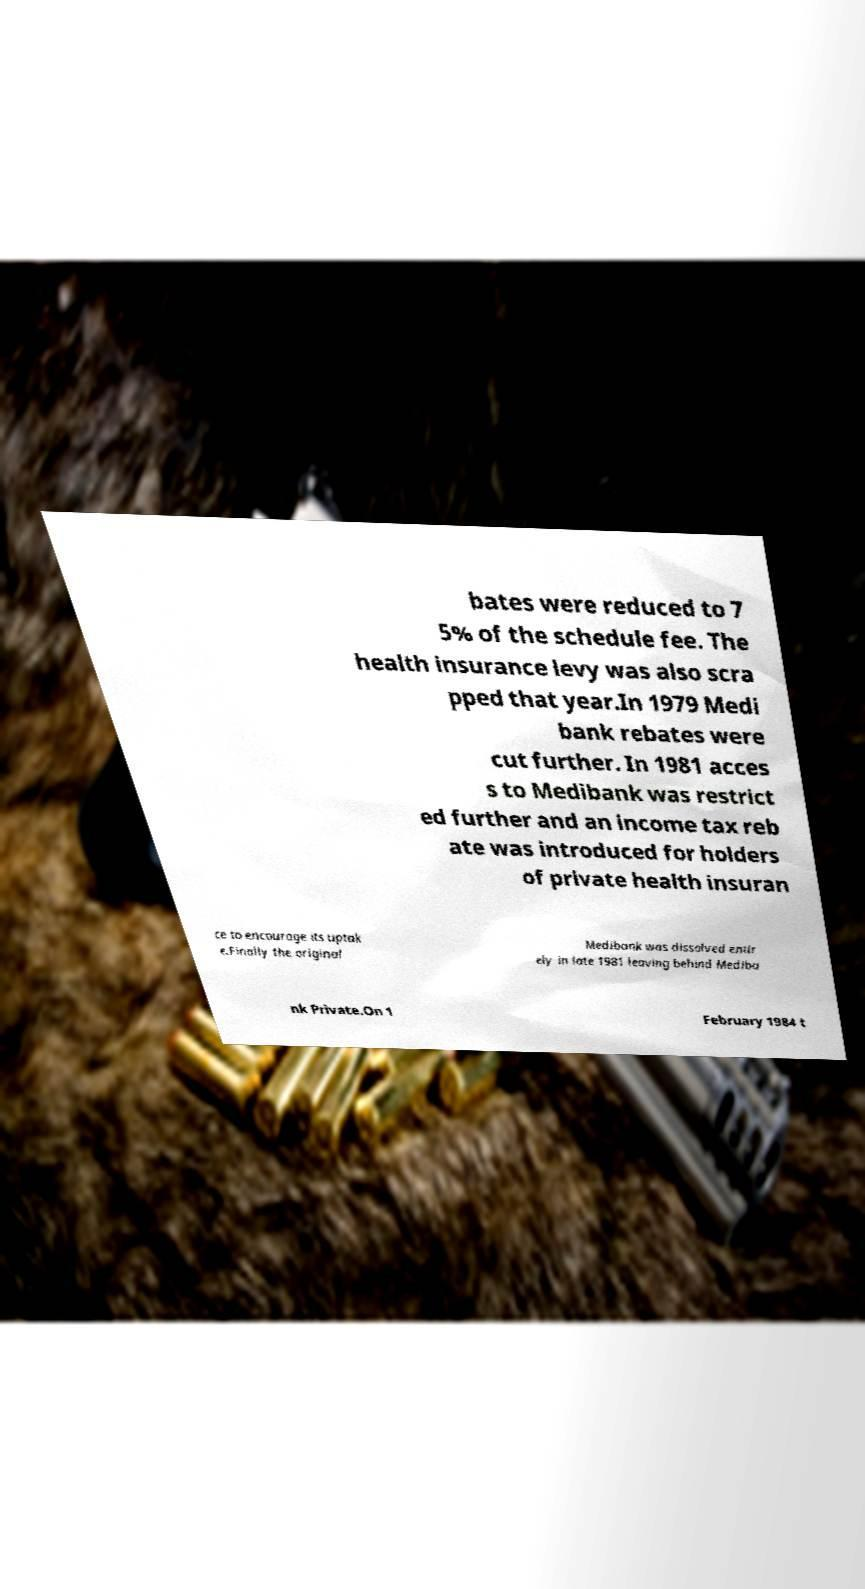Please identify and transcribe the text found in this image. bates were reduced to 7 5% of the schedule fee. The health insurance levy was also scra pped that year.In 1979 Medi bank rebates were cut further. In 1981 acces s to Medibank was restrict ed further and an income tax reb ate was introduced for holders of private health insuran ce to encourage its uptak e.Finally the original Medibank was dissolved entir ely in late 1981 leaving behind Mediba nk Private.On 1 February 1984 t 